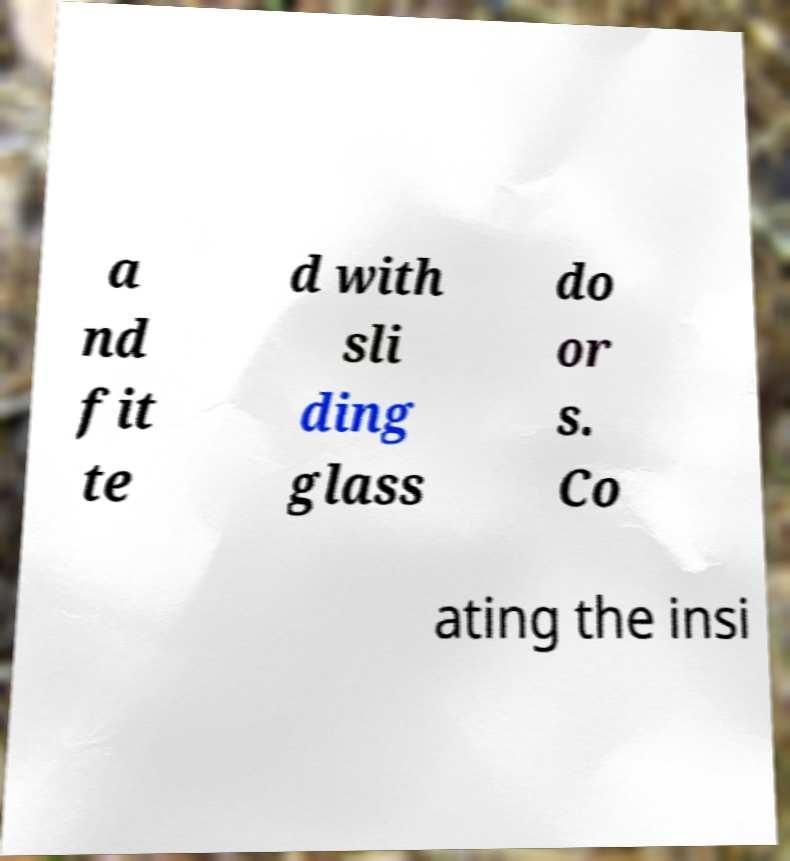There's text embedded in this image that I need extracted. Can you transcribe it verbatim? a nd fit te d with sli ding glass do or s. Co ating the insi 